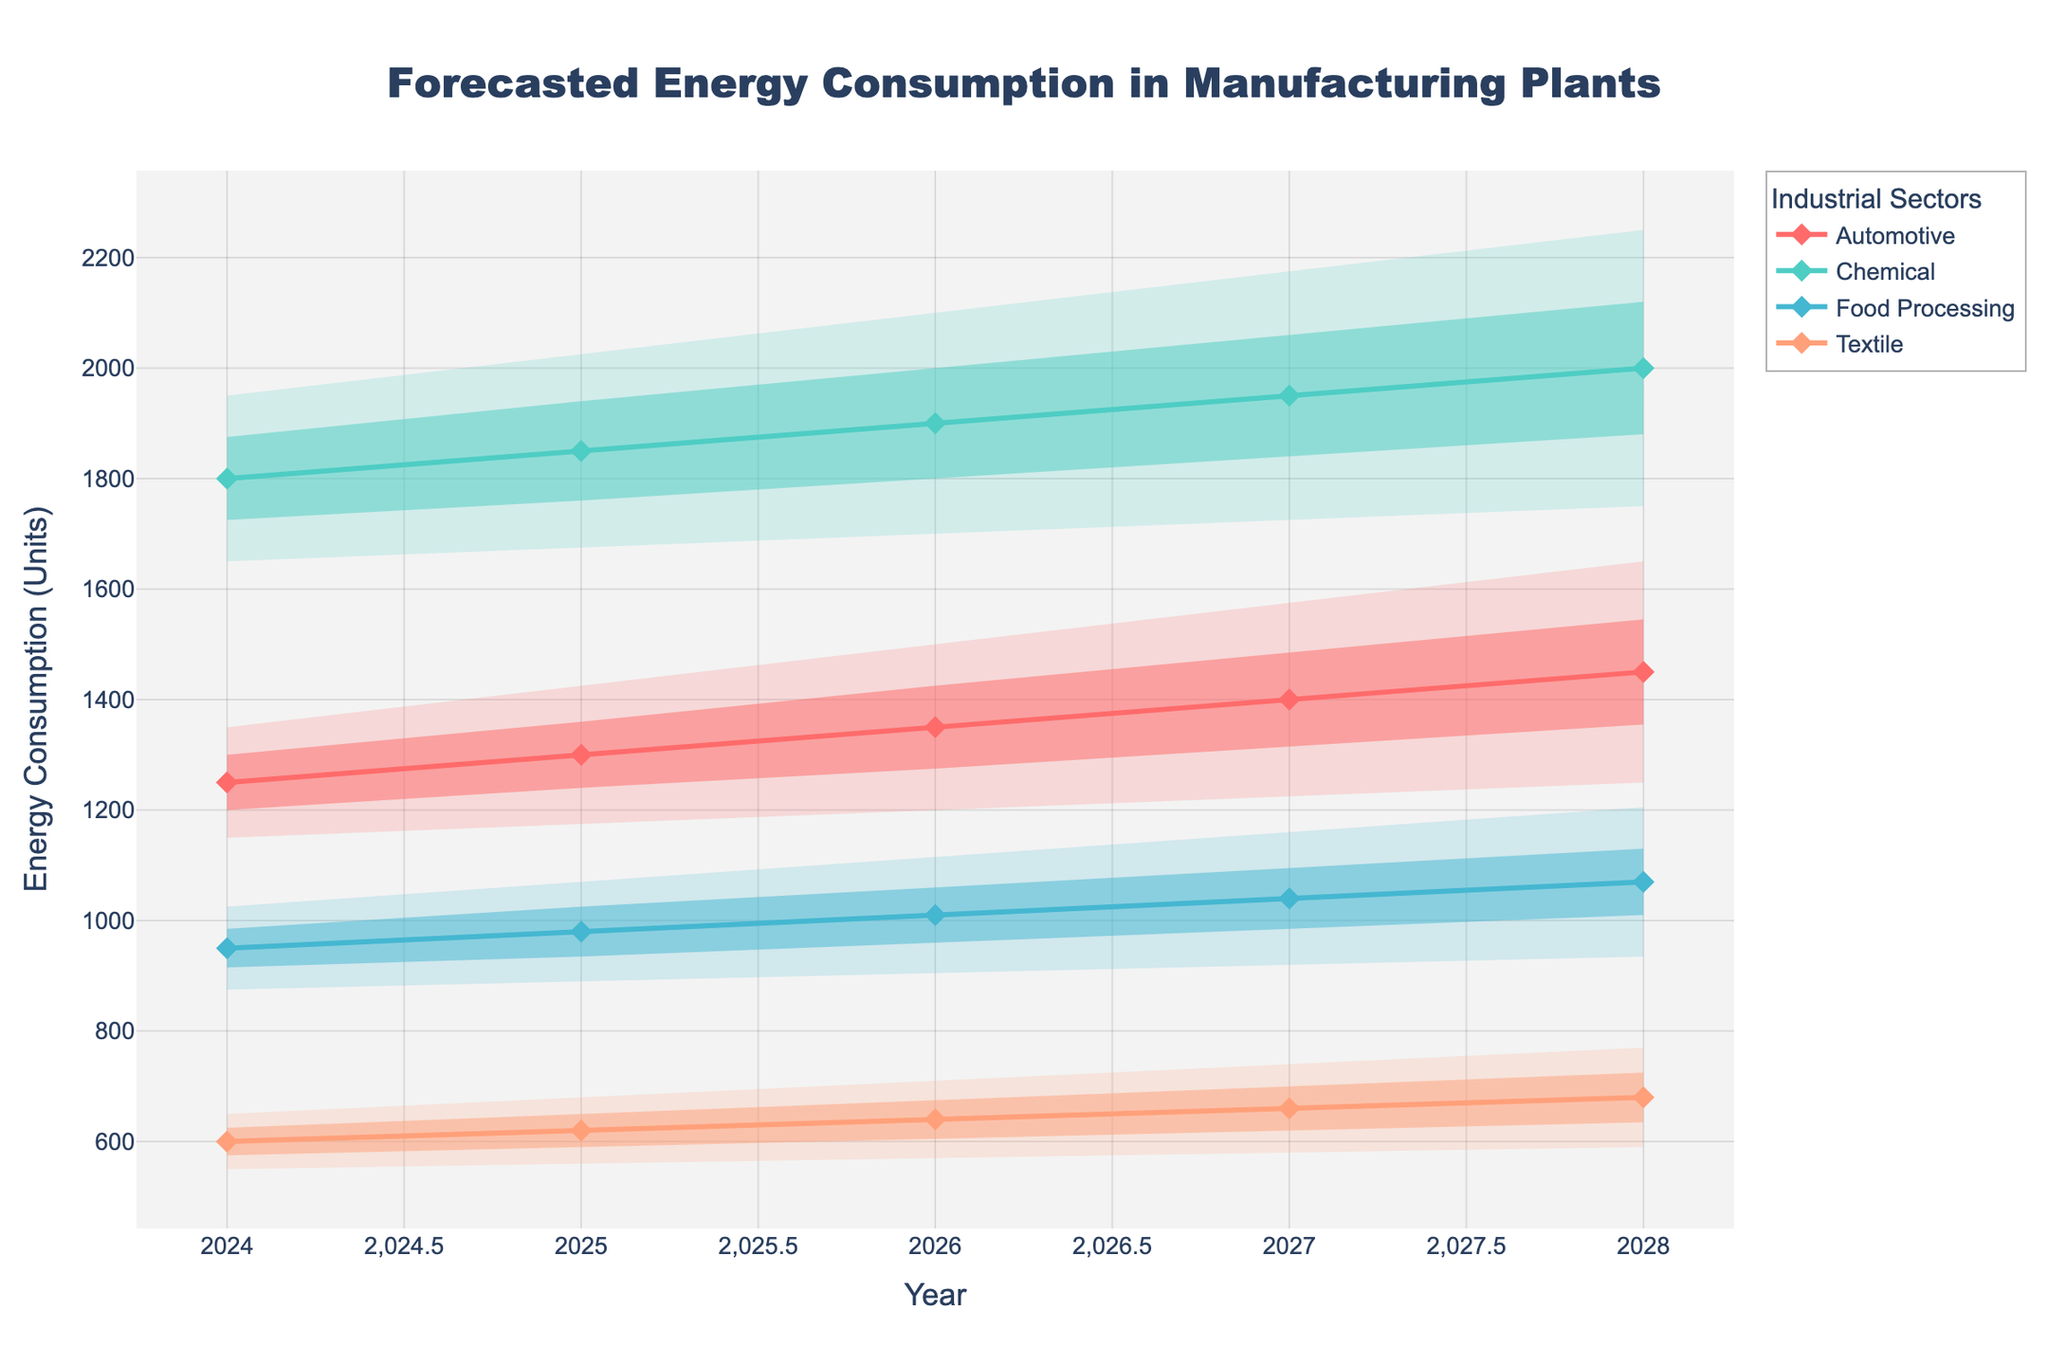What is the title of the chart? The title of the chart is usually placed at the top and often in larger font. In this case, it is given as 'Forecasted Energy Consumption in Manufacturing Plants'.
Answer: Forecasted Energy Consumption in Manufacturing Plants What does the x-axis represent? The x-axis usually represents the variable that changes over time in graphs like these. Here, it shows 'Year'.
Answer: Year Which sector has the highest median energy consumption in 2024? Looking at the median lines (solid lines with markers), the Chemical sector shows the highest median value for 2024, which is 1800 units.
Answer: Chemical What range does the 80% confidence interval cover for the Food Processing sector in 2025? The 80% confidence interval is represented by the shaded area between the upper 90% and lower 10% values. For Food Processing in 2025, this range is 890 to 1070 units.
Answer: 890-1070 units How does the energy consumption forecast for the Textile sector change from 2025 to 2026? Comparing the median lines or values, the Textile sector's median energy consumption slightly increases from 620 units in 2025 to 640 units in 2026.
Answer: Increases from 620 to 640 units What is the forecasted median energy consumption for the Automotive sector in 2027? The median lines with markers indicate this value. For the Automotive sector in 2027, it is 1400 units.
Answer: 1400 units Which sector has the smallest increase in median energy consumption from 2024 to 2028? By comparing the median values from 2024 to 2028 for each sector, the Food Processing sector shows the smallest increase, from 950 units to 1070 units, an increase of 120 units.
Answer: Food Processing (120 units) Which two sectors have overlapping 50% confidence intervals in 2028? The 50% confidence intervals are represented by the darker shaded areas. In 2028, the Automotive and Chemical sectors have overlapping 50% confidence intervals.
Answer: Automotive and Chemical Are there any years where the median energy consumption forecast for all sectors is increasing? Checking the progression of median lines for each sector across years, we can see that from 2025 to 2026, the median energy consumption for all sectors increases.
Answer: 2025 to 2026 What is the predicted upper bound (90% CI) for Chemical sector energy consumption in 2028? The data shows that the upper 90% confidence interval for the Chemical sector in 2028 is 2250 units.
Answer: 2250 units 